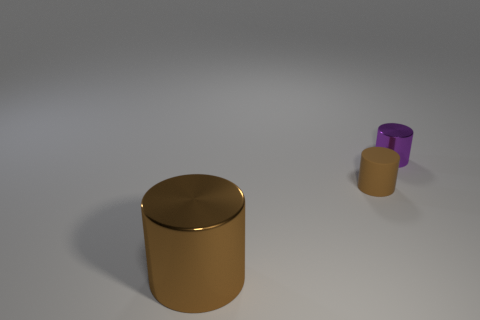Add 1 tiny rubber cylinders. How many objects exist? 4 Subtract all shiny cylinders. How many cylinders are left? 1 Subtract all purple cylinders. How many cylinders are left? 2 Subtract 2 cylinders. How many cylinders are left? 1 Add 3 small metallic cubes. How many small metallic cubes exist? 3 Subtract 0 gray spheres. How many objects are left? 3 Subtract all yellow cylinders. Subtract all red spheres. How many cylinders are left? 3 Subtract all blue balls. How many gray cylinders are left? 0 Subtract all tiny shiny objects. Subtract all small purple things. How many objects are left? 1 Add 3 brown objects. How many brown objects are left? 5 